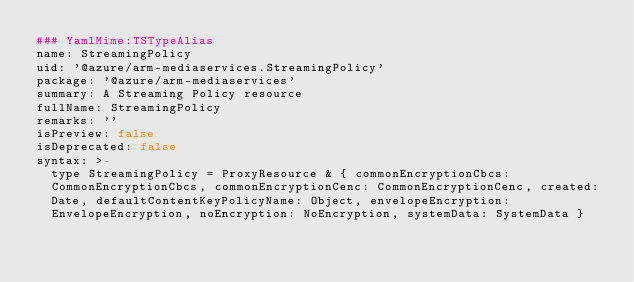Convert code to text. <code><loc_0><loc_0><loc_500><loc_500><_YAML_>### YamlMime:TSTypeAlias
name: StreamingPolicy
uid: '@azure/arm-mediaservices.StreamingPolicy'
package: '@azure/arm-mediaservices'
summary: A Streaming Policy resource
fullName: StreamingPolicy
remarks: ''
isPreview: false
isDeprecated: false
syntax: >-
  type StreamingPolicy = ProxyResource & { commonEncryptionCbcs:
  CommonEncryptionCbcs, commonEncryptionCenc: CommonEncryptionCenc, created:
  Date, defaultContentKeyPolicyName: Object, envelopeEncryption:
  EnvelopeEncryption, noEncryption: NoEncryption, systemData: SystemData }
</code> 